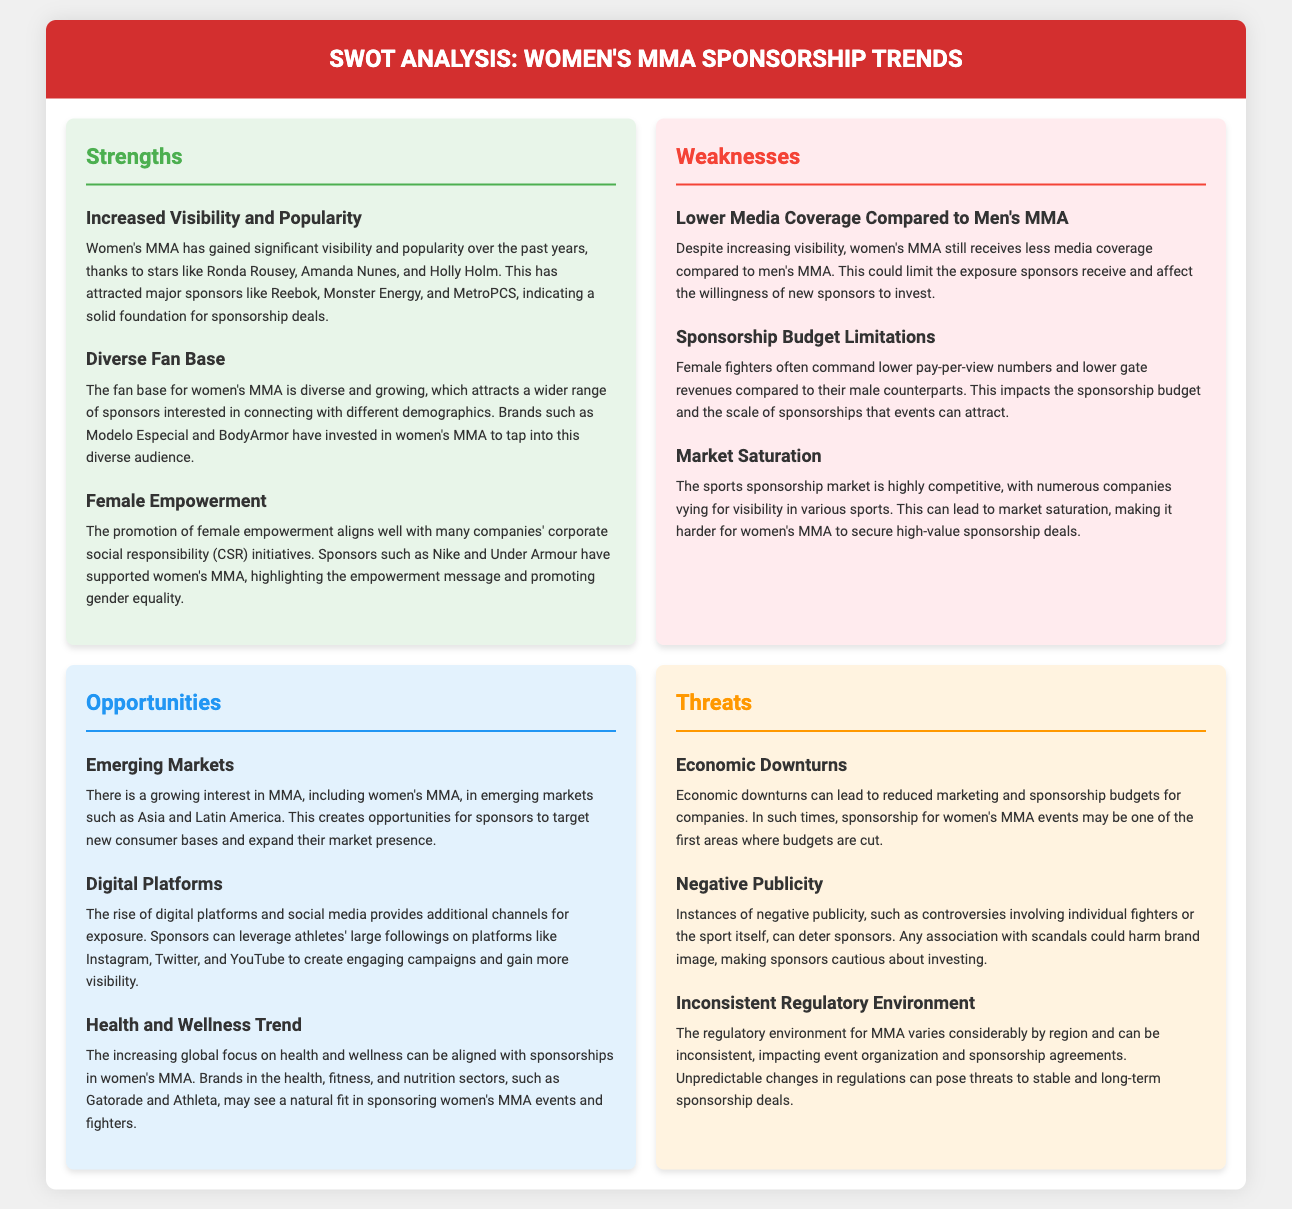What is a major strength of women's MMA? Increased visibility and popularity have greatly contributed to the sponsorship landscape, highlighting key athletes that attract brands.
Answer: Increased visibility and popularity Which company is highlighted for its support of female empowerment? Nike is mentioned as a sponsor that aligns its corporate social responsibility initiatives with the empowerment message of women's MMA.
Answer: Nike What is a primary weakness in women's MMA sponsorship? Women's MMA sponsorship faces challenges such as lower media coverage compared to its male counterparts, which affects sponsorship exposure.
Answer: Lower media coverage compared to men's MMA What emerging markets are noted for potential growth in women’s MMA? The document mentions a growing interest in women's MMA in Asia and Latin America as new consumer bases for sponsors.
Answer: Asia and Latin America Which trend can brands align with to enhance their sponsorship efforts? The increasing focus on health and wellness can create synergies with sponsors in relevant sectors like fitness and nutrition.
Answer: Health and wellness trend What is a significant threat to sponsorship in women's MMA? Economic downturns can lead to reduced marketing and sponsorship budgets, impacting investment in women's MMA events.
Answer: Economic downturns What demographic appeal does women's MMA have? The diverse fan base is notable as it attracts a wide range of sponsors looking to connect with various demographics.
Answer: Diverse fan base Which company is mentioned as a recent sponsor of women’s MMA? BodyArmor is noted as a brand that has invested in women’s MMA, aiming to reach new audiences.
Answer: BodyArmor 